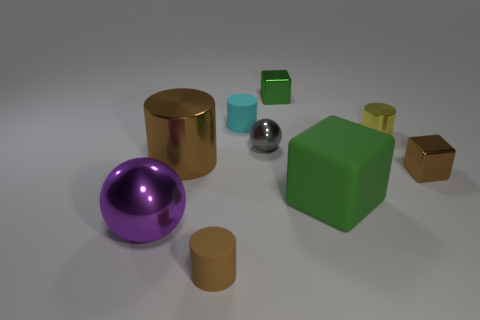What number of things are tiny shiny cylinders or green things? In the image, there is one tiny shiny cylinder, which is the smaller silver object, and two green things, which are the lighter green cube and the darker green cube. Therefore, the total count of tiny shiny cylinders or green things is three. 